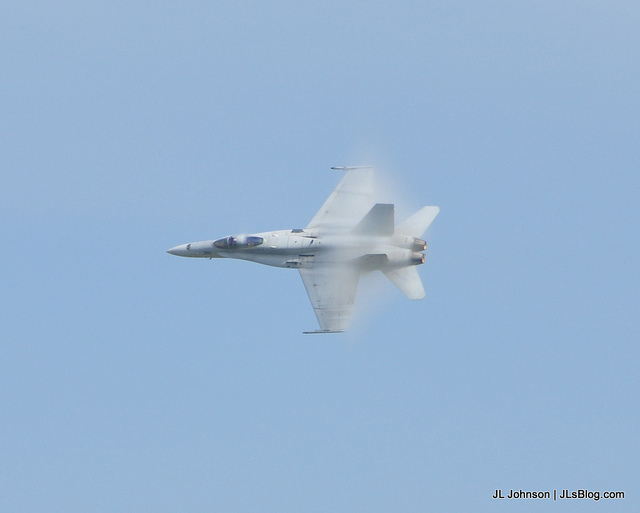<image>Which photographer took this image? I don't know which photographer took this image. But it can be seen 'jl johnson'. Which photographer took this image? I don't know which photographer took this image. It can be JL Johnson or someone else. 